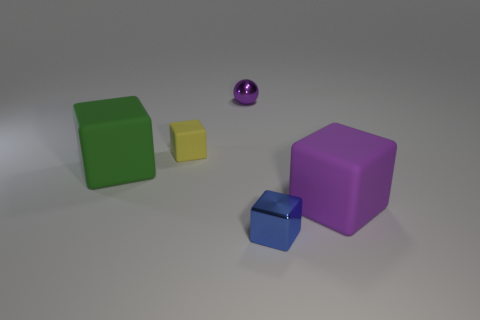How are the shadows in the image affecting the perception of the shapes? The shadows in the image provide a sense of depth and dimension to the objects. The way they are cast indicates a light source from the upper left, helping to visually separate the objects and convey information about their size and spatial relationship. Do the shadows tell us anything about the texture of the surface? Yes, the shadows have soft edges and are smoothly gradiented, hinting that the surface might be smooth and not highly textured. If the surface were rough or irregular, the shadows would likely appear more diffused or broken up. 